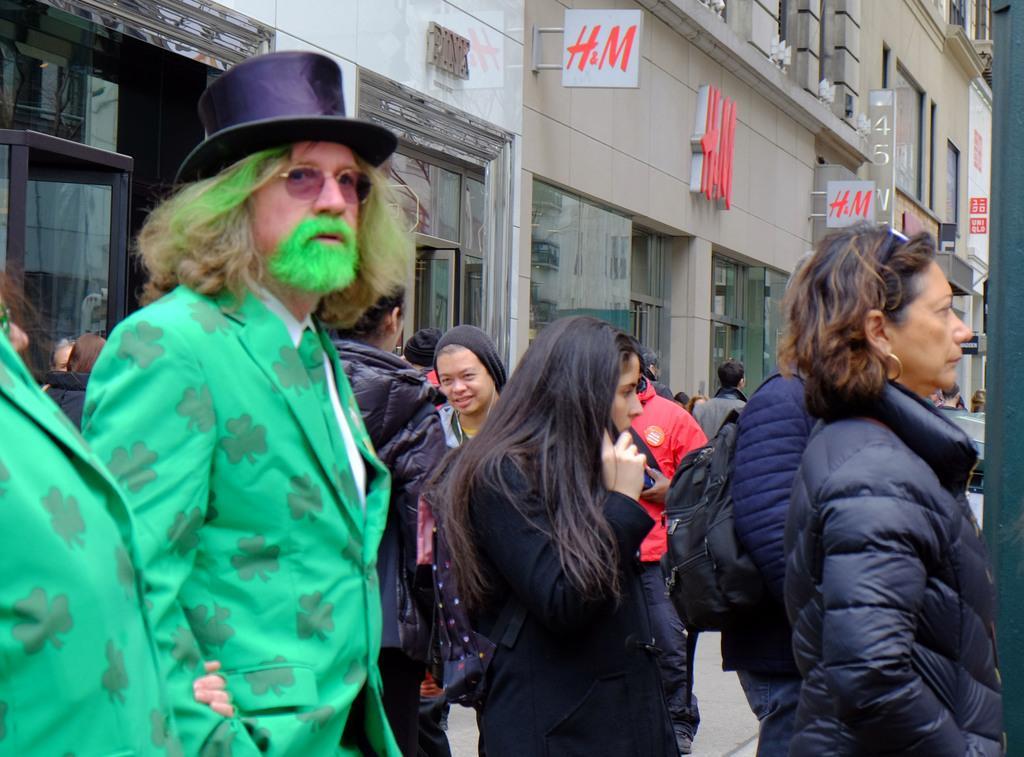Describe this image in one or two sentences. On the left side, there are two persons in green color jacket. On the right side, there are persons in different color dresses on the road. In the background, there are hoardings attached to the walls of the buildings which are having windows and there are other persons. 